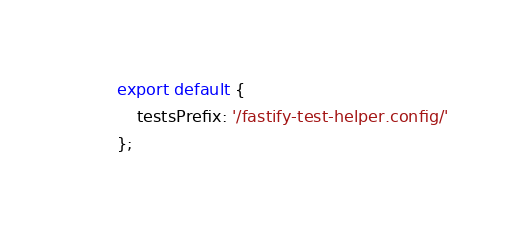Convert code to text. <code><loc_0><loc_0><loc_500><loc_500><_JavaScript_>export default {
	testsPrefix: '/fastify-test-helper.config/'
};
</code> 